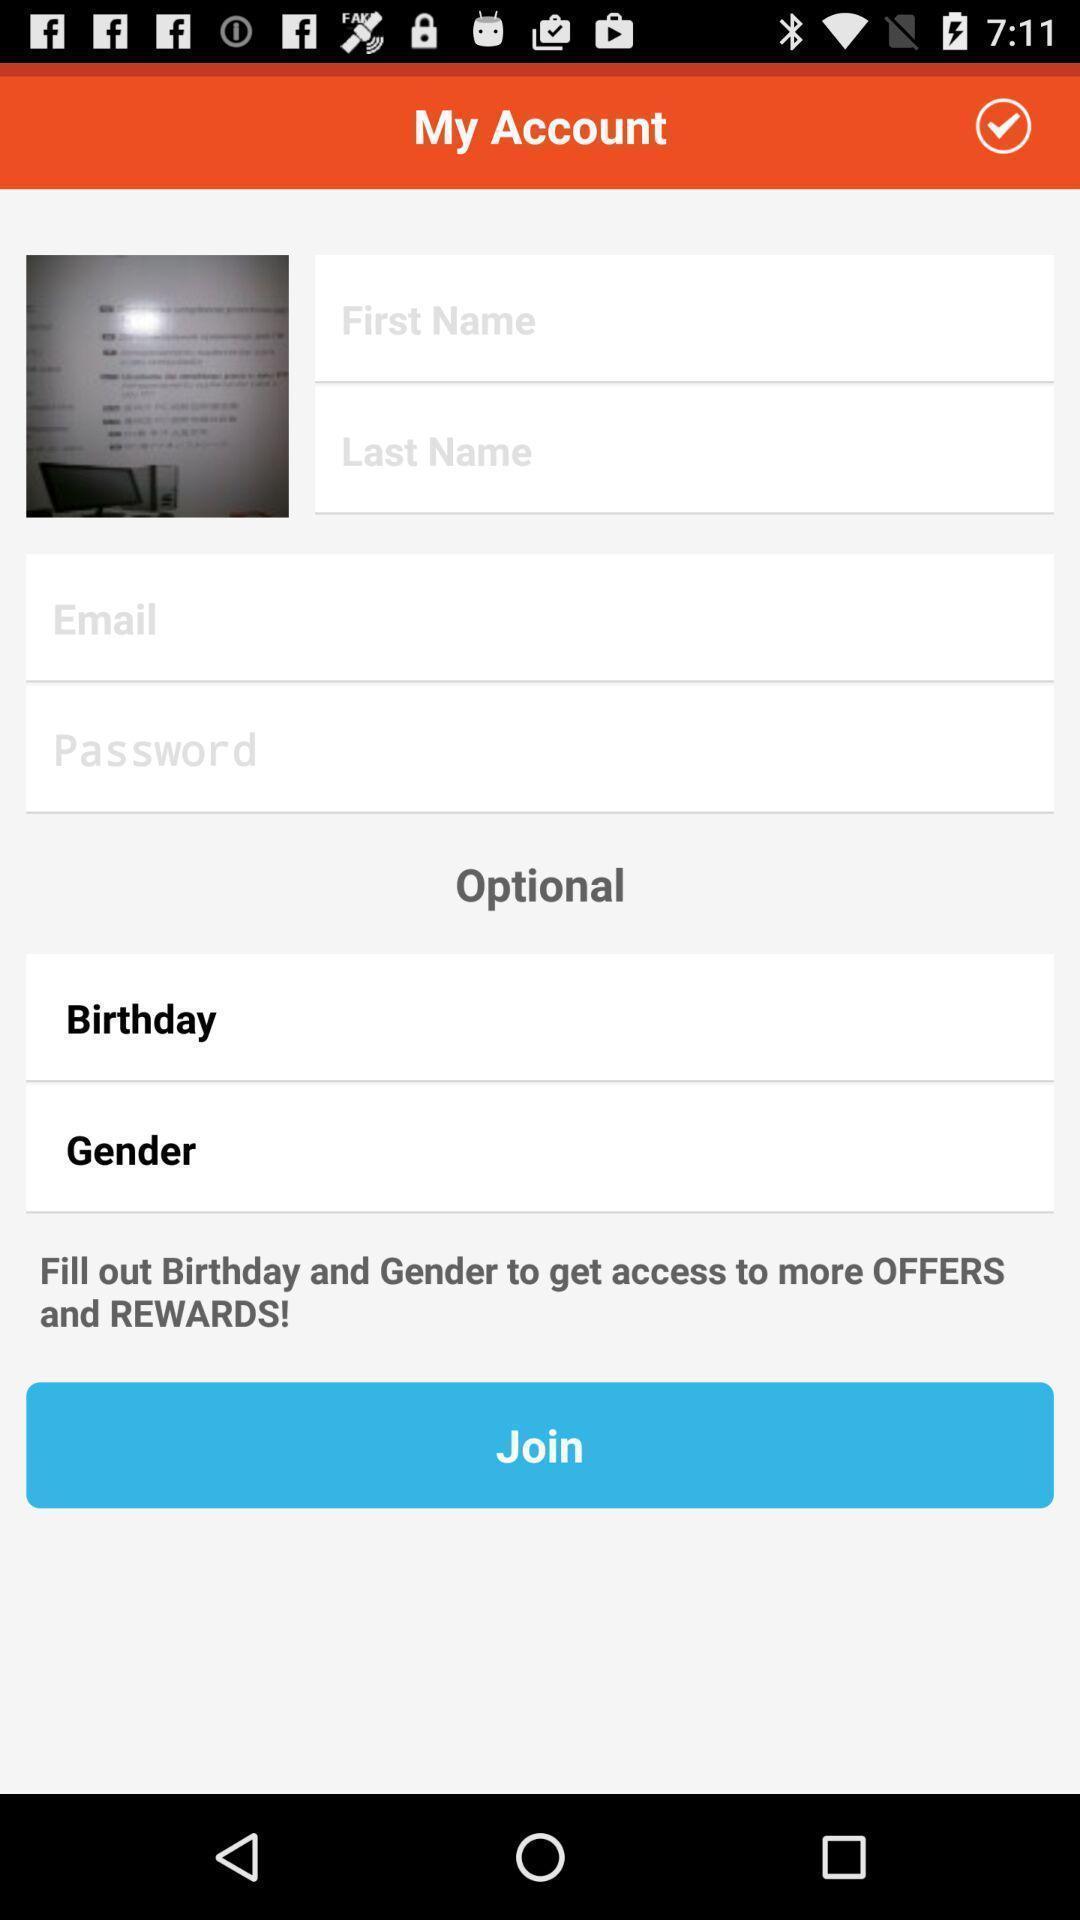Explain the elements present in this screenshot. Sign page. 